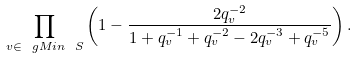<formula> <loc_0><loc_0><loc_500><loc_500>\prod _ { v \in \ g M i n \ S } \left ( 1 - \frac { 2 q _ { v } ^ { - 2 } } { 1 + q _ { v } ^ { - 1 } + q _ { v } ^ { - 2 } - 2 q _ { v } ^ { - 3 } + q _ { v } ^ { - 5 } } \right ) .</formula> 